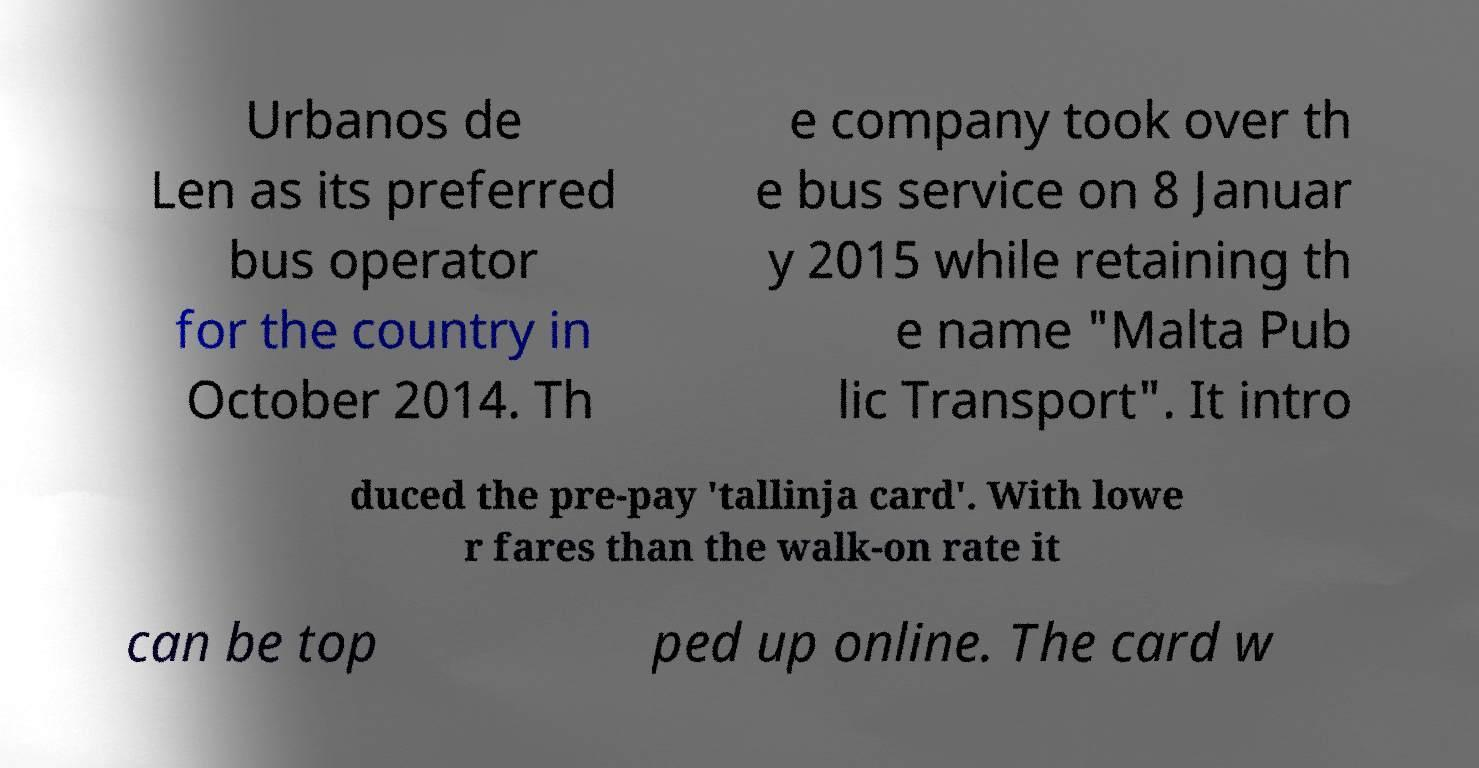For documentation purposes, I need the text within this image transcribed. Could you provide that? Urbanos de Len as its preferred bus operator for the country in October 2014. Th e company took over th e bus service on 8 Januar y 2015 while retaining th e name "Malta Pub lic Transport". It intro duced the pre-pay 'tallinja card'. With lowe r fares than the walk-on rate it can be top ped up online. The card w 